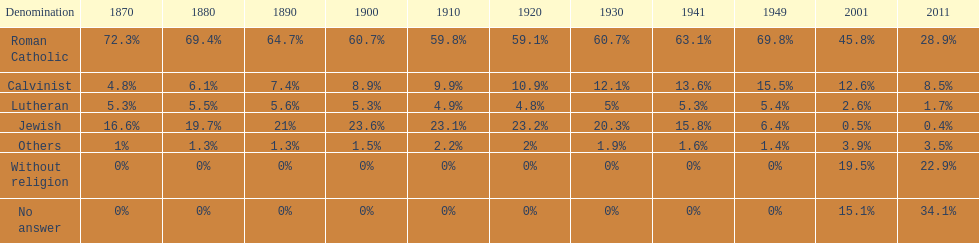What is the total percentage of people who identified as religious in 2011? 43%. 